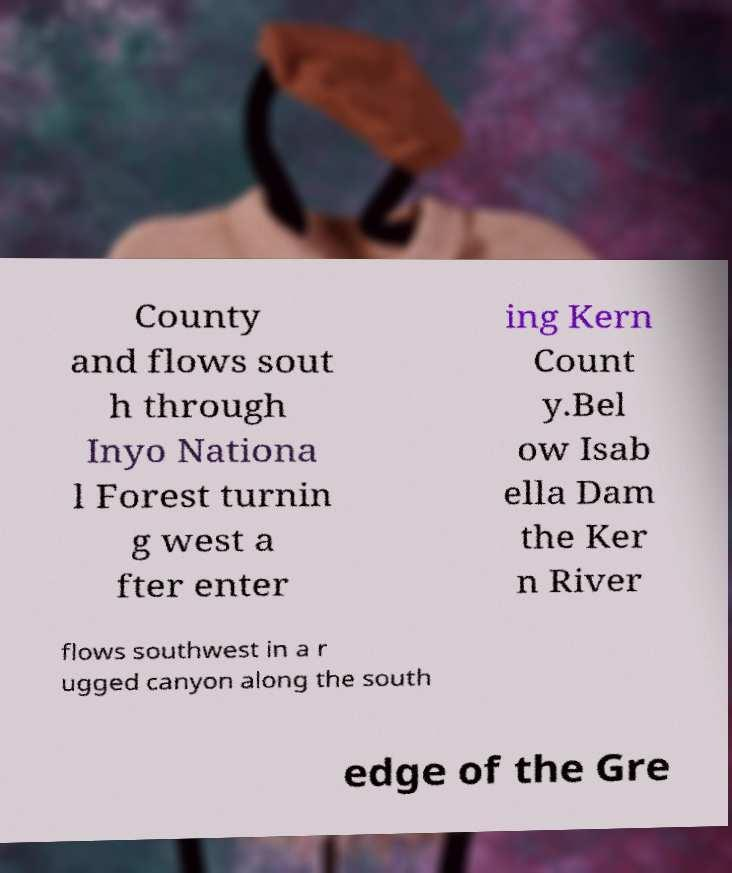I need the written content from this picture converted into text. Can you do that? County and flows sout h through Inyo Nationa l Forest turnin g west a fter enter ing Kern Count y.Bel ow Isab ella Dam the Ker n River flows southwest in a r ugged canyon along the south edge of the Gre 